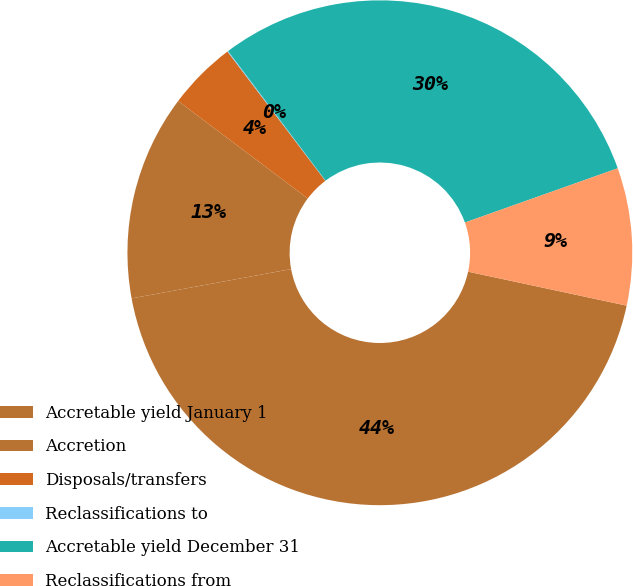Convert chart. <chart><loc_0><loc_0><loc_500><loc_500><pie_chart><fcel>Accretable yield January 1<fcel>Accretion<fcel>Disposals/transfers<fcel>Reclassifications to<fcel>Accretable yield December 31<fcel>Reclassifications from<nl><fcel>43.75%<fcel>13.16%<fcel>4.42%<fcel>0.05%<fcel>29.84%<fcel>8.79%<nl></chart> 